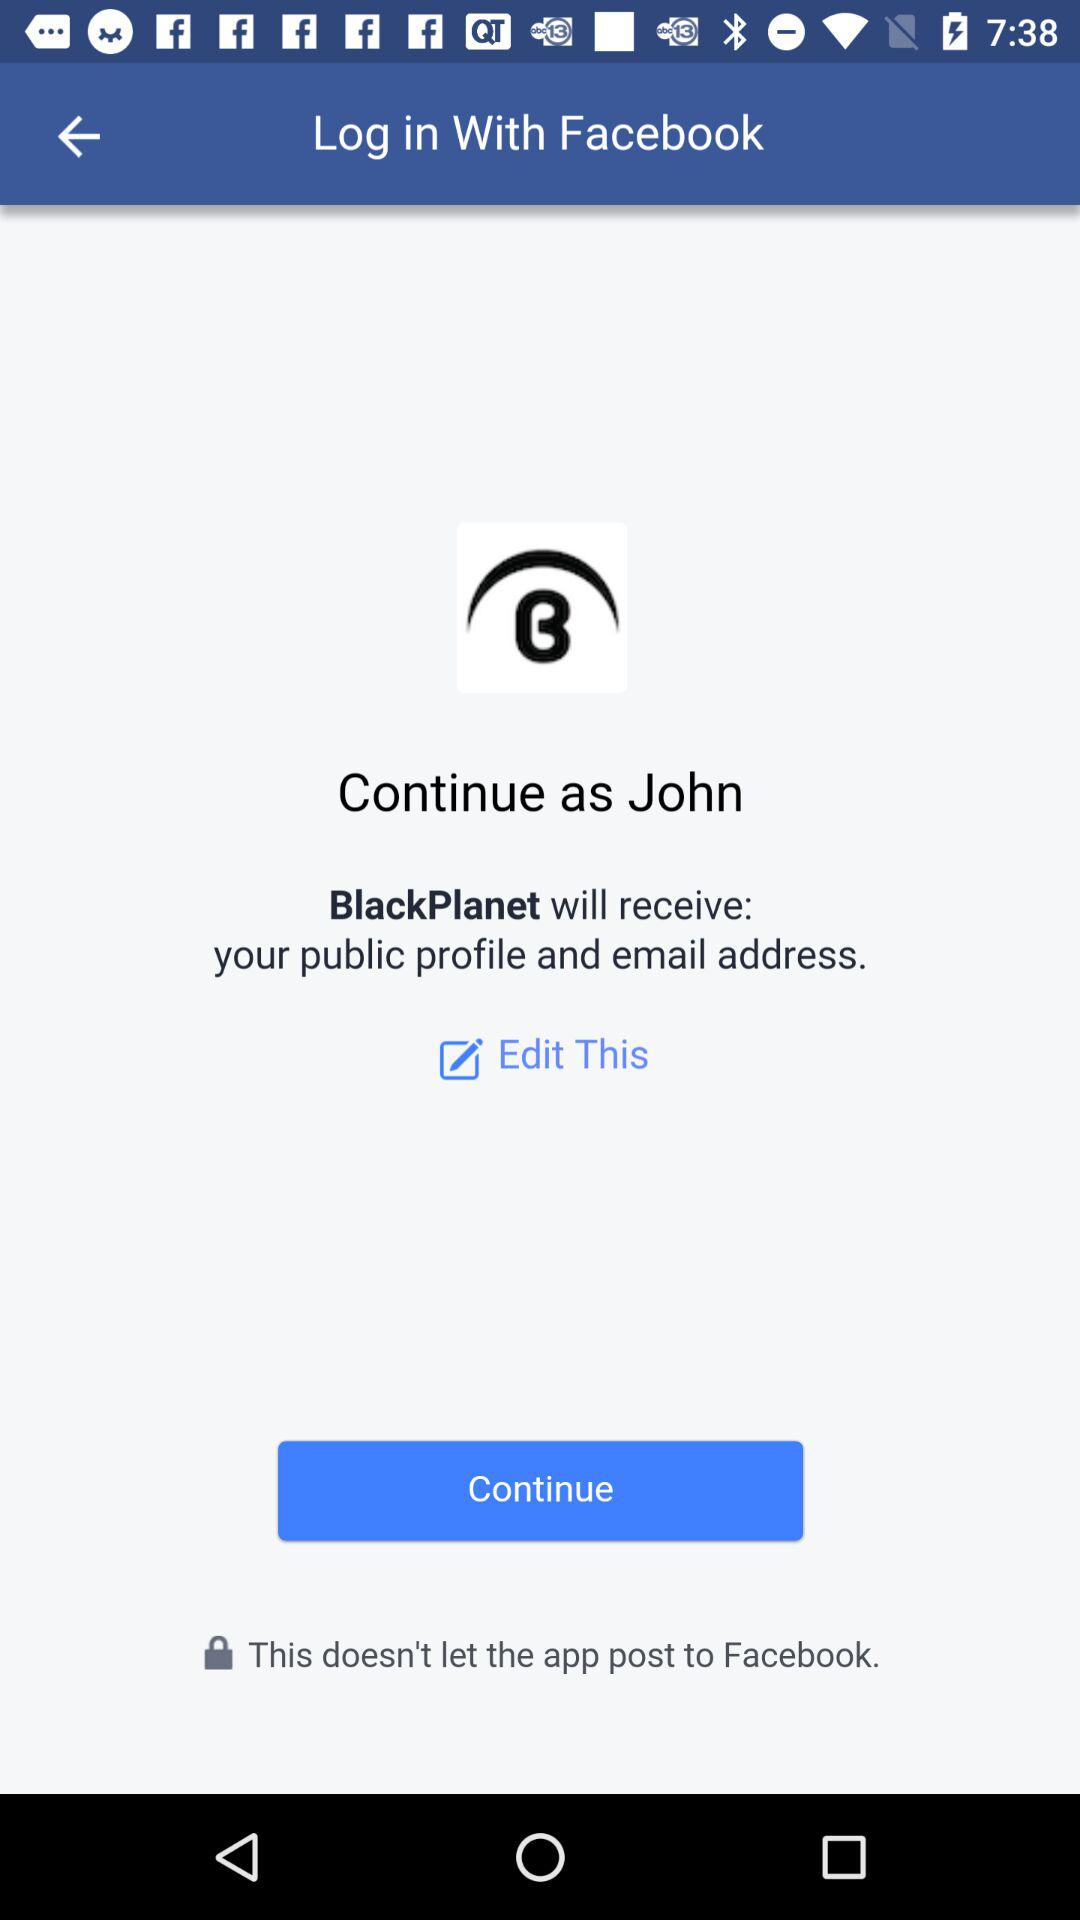What application will receive a public profile and email address? The application is "BlackPlanet". 